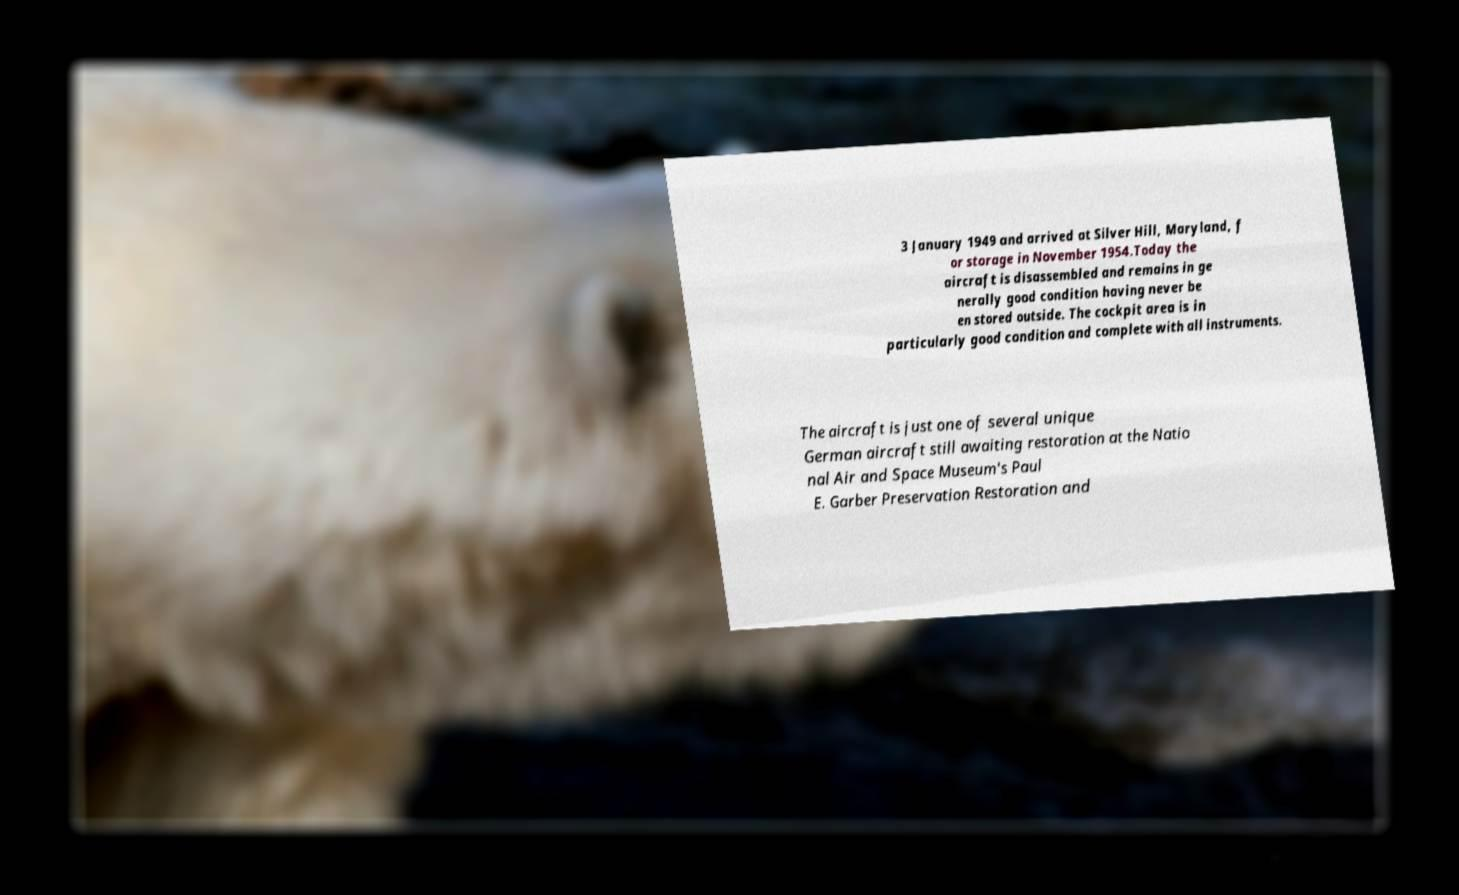Could you extract and type out the text from this image? 3 January 1949 and arrived at Silver Hill, Maryland, f or storage in November 1954.Today the aircraft is disassembled and remains in ge nerally good condition having never be en stored outside. The cockpit area is in particularly good condition and complete with all instruments. The aircraft is just one of several unique German aircraft still awaiting restoration at the Natio nal Air and Space Museum's Paul E. Garber Preservation Restoration and 